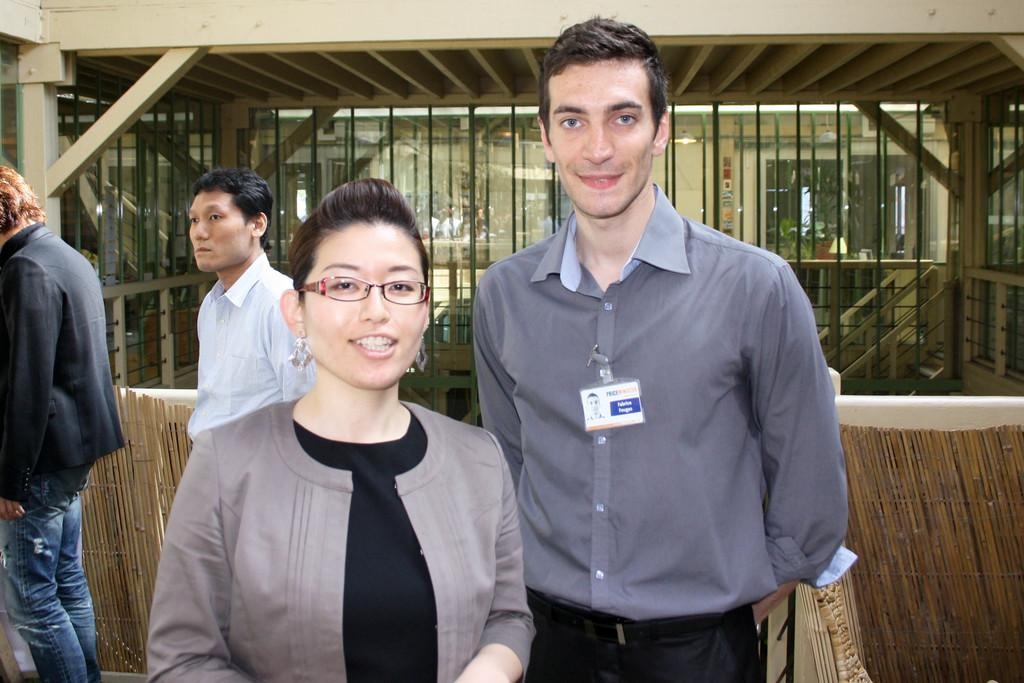What is happening in the image? There are people standing in the image. Can you describe the man in the image? The man is wearing an ID card. What can be seen in the background of the image? There is a building in the background of the image. What type of barrier is present in the image? There is a metal fence in the image. How many bulbs are hanging from the ceiling in the image? There are no bulbs visible in the image. Can you describe the bat that is flying in the image? There are no bats present in the image. 